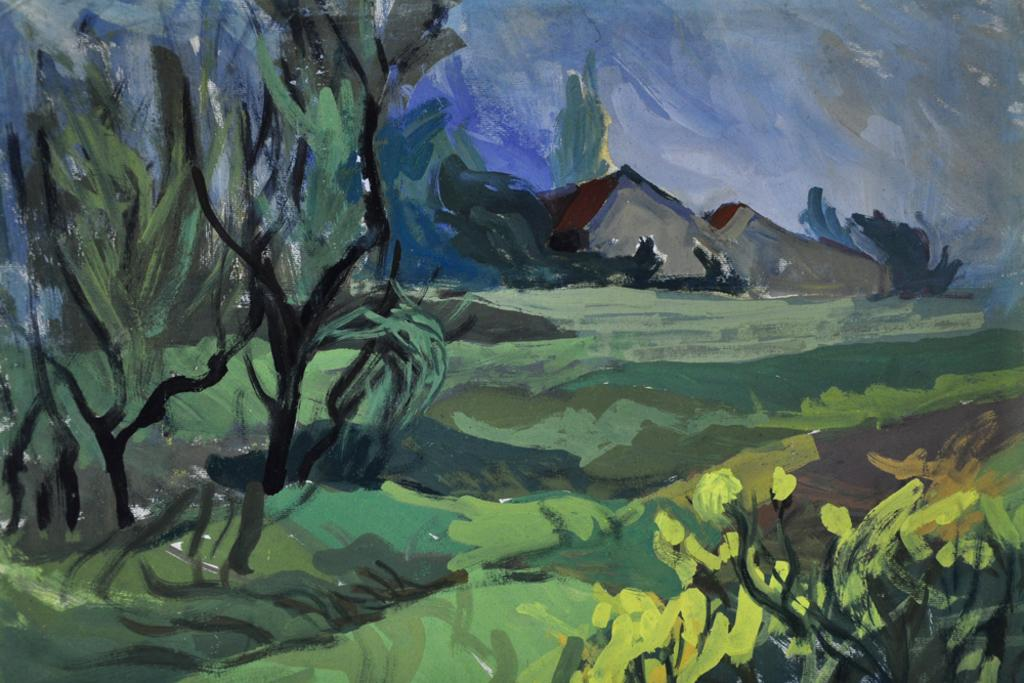What type of artwork is depicted in the image? The image is a painting. What natural elements can be seen in the painting? There are trees and grass at the bottom of the painting. What man-made structures are present in the painting? There are sheds in the painting. What is visible in the background of the painting? There is sky visible in the background of the painting. What type of vegetation is present at the bottom of the painting? There are plants at the bottom of the painting. What type of doll is sitting on the step in the painting? There is no doll or step present in the painting; it features trees, sheds, grass, plants, and sky. 